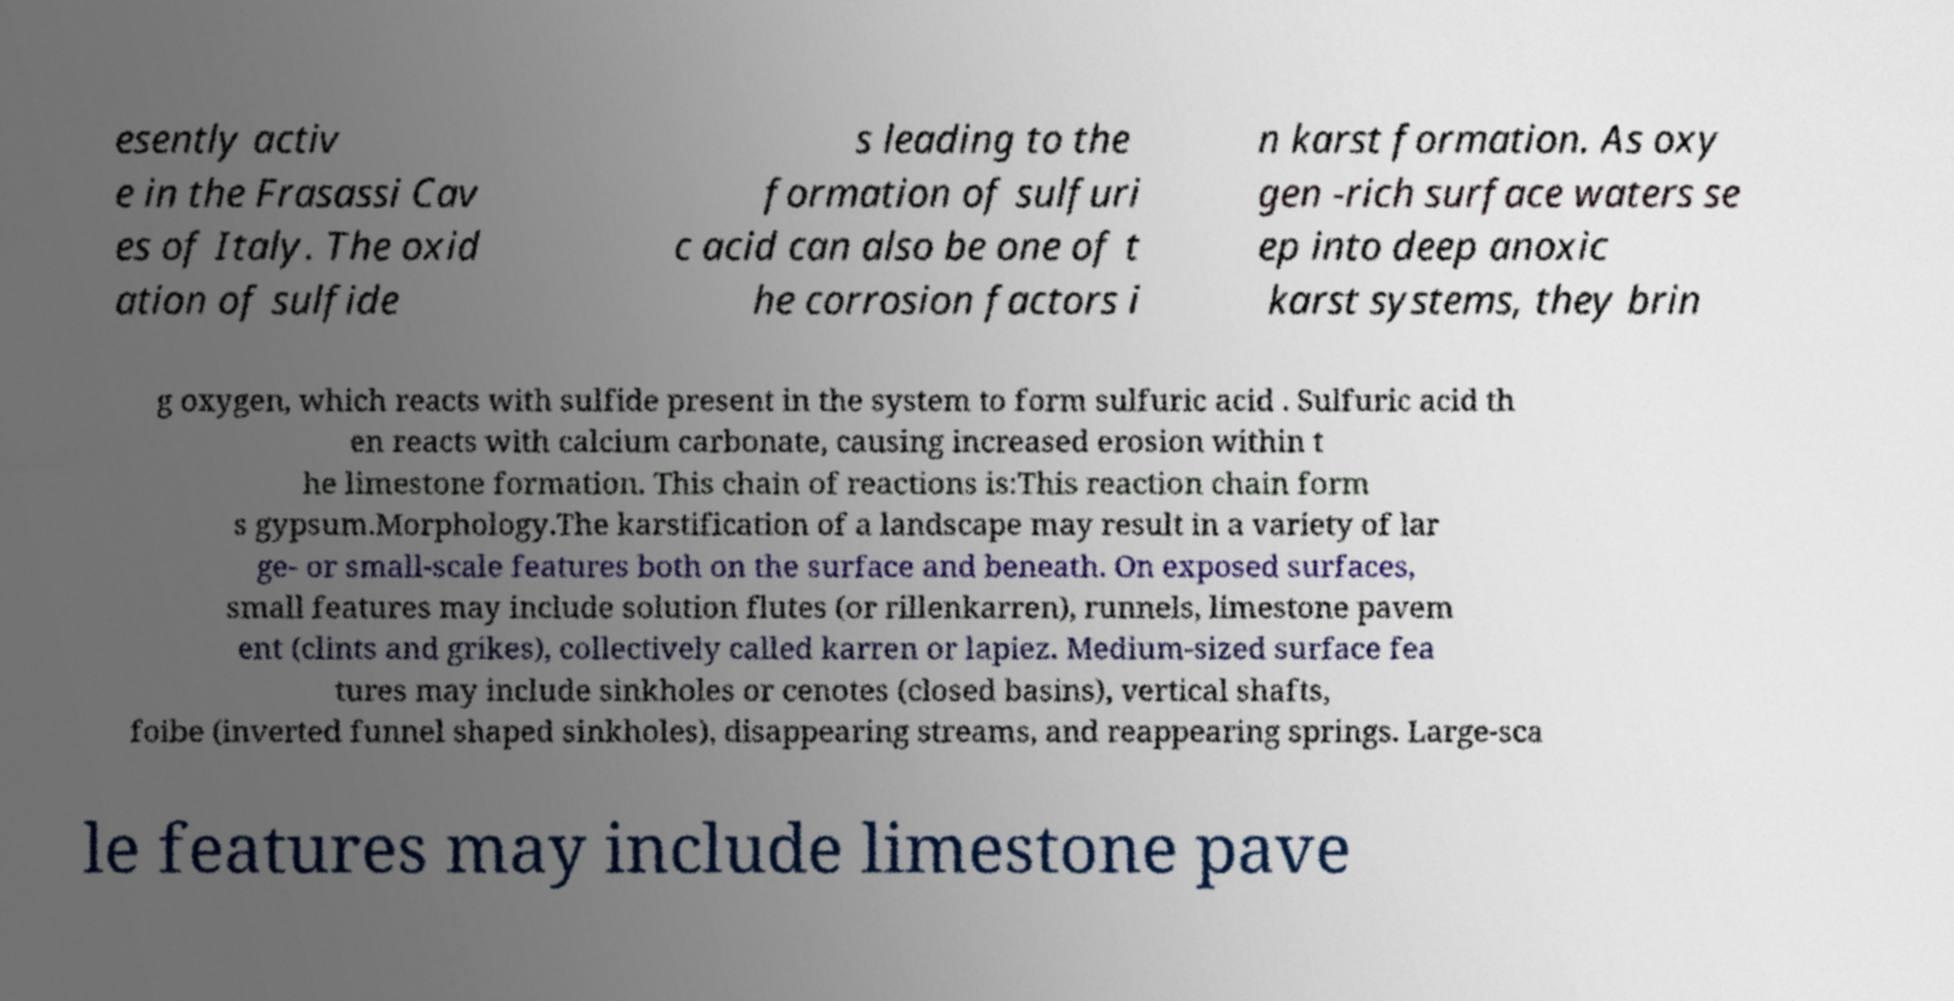For documentation purposes, I need the text within this image transcribed. Could you provide that? esently activ e in the Frasassi Cav es of Italy. The oxid ation of sulfide s leading to the formation of sulfuri c acid can also be one of t he corrosion factors i n karst formation. As oxy gen -rich surface waters se ep into deep anoxic karst systems, they brin g oxygen, which reacts with sulfide present in the system to form sulfuric acid . Sulfuric acid th en reacts with calcium carbonate, causing increased erosion within t he limestone formation. This chain of reactions is:This reaction chain form s gypsum.Morphology.The karstification of a landscape may result in a variety of lar ge- or small-scale features both on the surface and beneath. On exposed surfaces, small features may include solution flutes (or rillenkarren), runnels, limestone pavem ent (clints and grikes), collectively called karren or lapiez. Medium-sized surface fea tures may include sinkholes or cenotes (closed basins), vertical shafts, foibe (inverted funnel shaped sinkholes), disappearing streams, and reappearing springs. Large-sca le features may include limestone pave 